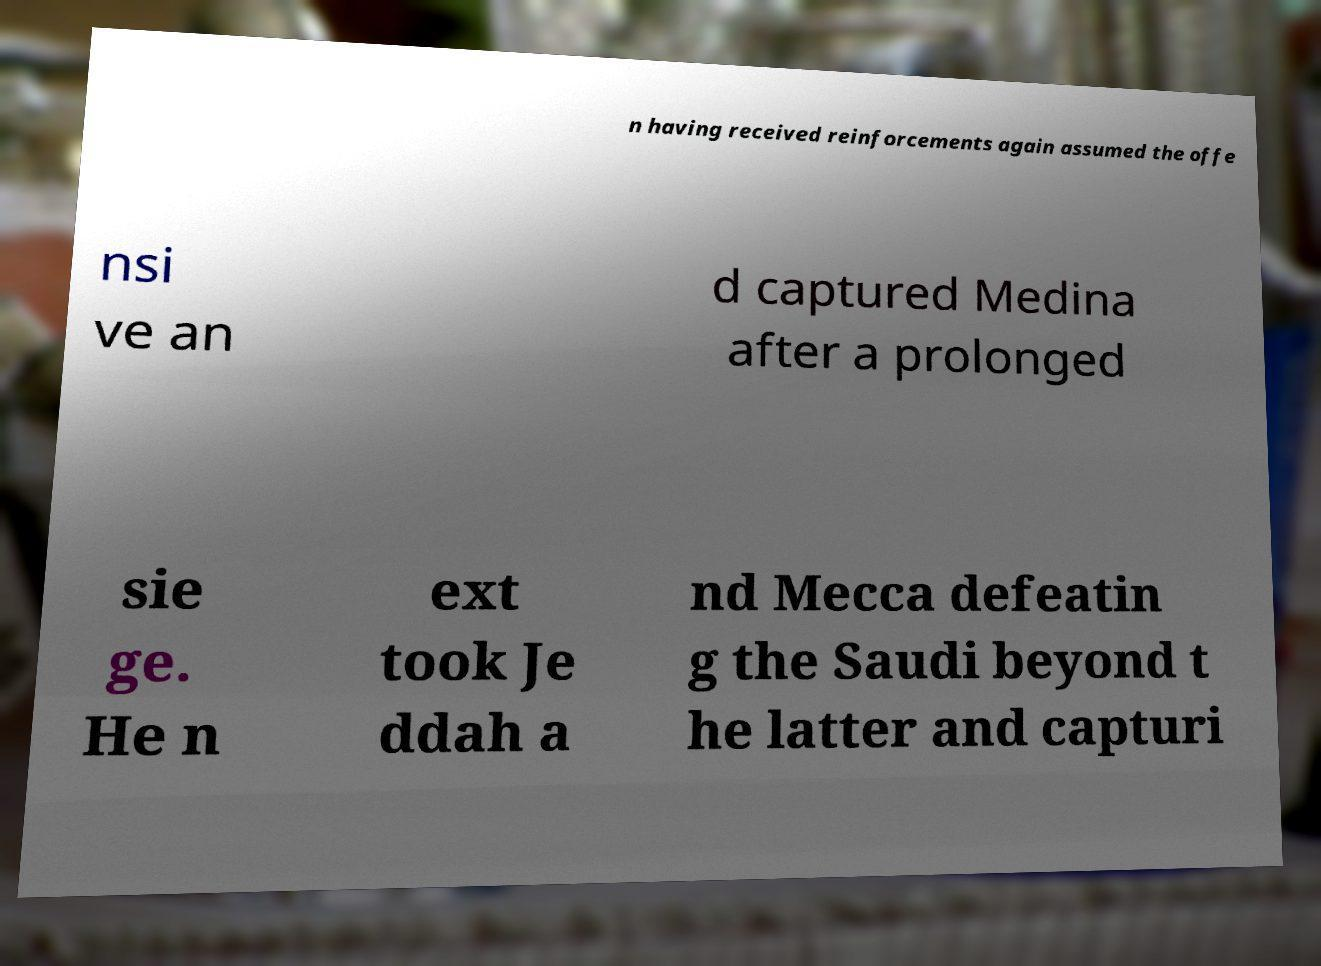I need the written content from this picture converted into text. Can you do that? n having received reinforcements again assumed the offe nsi ve an d captured Medina after a prolonged sie ge. He n ext took Je ddah a nd Mecca defeatin g the Saudi beyond t he latter and capturi 